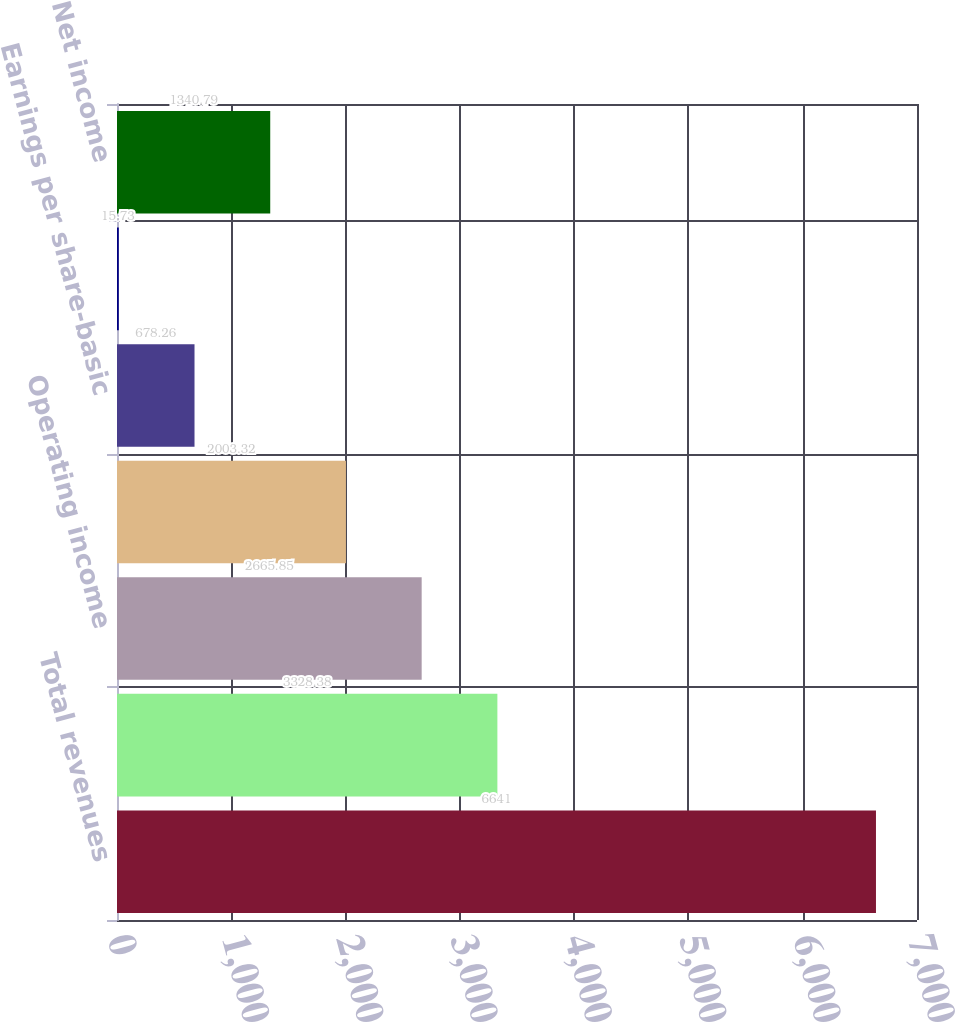Convert chart. <chart><loc_0><loc_0><loc_500><loc_500><bar_chart><fcel>Total revenues<fcel>Gross profit<fcel>Operating income<fcel>Net income (1)<fcel>Earnings per share-basic<fcel>Earnings per share-diluted (3)<fcel>Net income<nl><fcel>6641<fcel>3328.38<fcel>2665.85<fcel>2003.32<fcel>678.26<fcel>15.73<fcel>1340.79<nl></chart> 